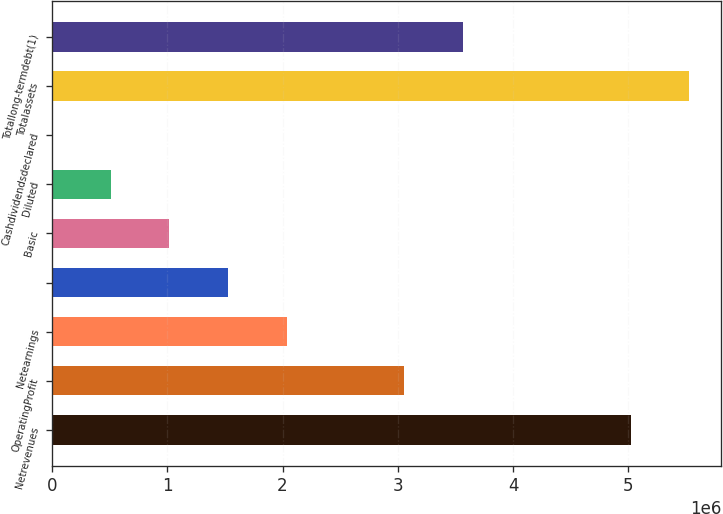Convert chart. <chart><loc_0><loc_0><loc_500><loc_500><bar_chart><fcel>Netrevenues<fcel>OperatingProfit<fcel>Netearnings<fcel>Unnamed: 3<fcel>Basic<fcel>Diluted<fcel>Cashdividendsdeclared<fcel>Totalassets<fcel>Totallong-termdebt(1)<nl><fcel>5.01982e+06<fcel>3.05482e+06<fcel>2.03655e+06<fcel>1.52741e+06<fcel>1.01827e+06<fcel>509138<fcel>2.04<fcel>5.52896e+06<fcel>3.56396e+06<nl></chart> 